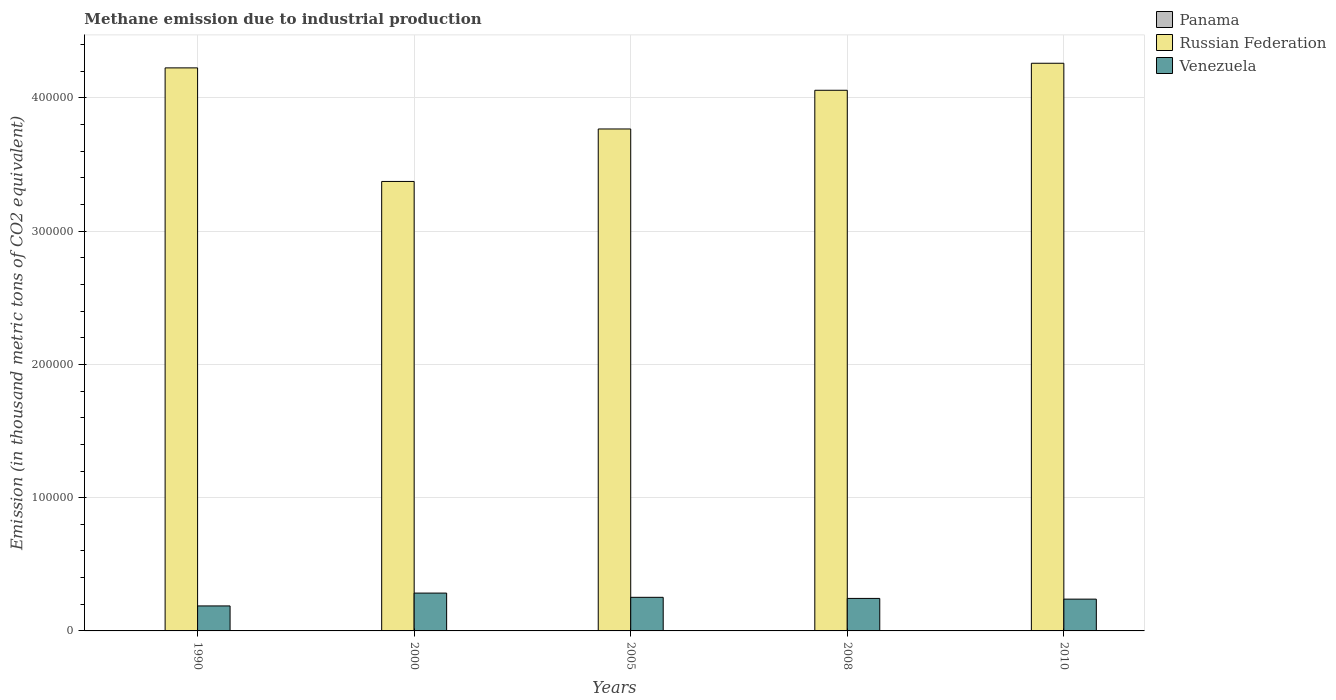How many different coloured bars are there?
Offer a terse response. 3. How many groups of bars are there?
Make the answer very short. 5. What is the label of the 2nd group of bars from the left?
Offer a terse response. 2000. In how many cases, is the number of bars for a given year not equal to the number of legend labels?
Offer a terse response. 0. What is the amount of methane emitted in Russian Federation in 2010?
Keep it short and to the point. 4.26e+05. Across all years, what is the maximum amount of methane emitted in Russian Federation?
Your response must be concise. 4.26e+05. Across all years, what is the minimum amount of methane emitted in Venezuela?
Offer a terse response. 1.88e+04. What is the total amount of methane emitted in Venezuela in the graph?
Provide a short and direct response. 1.21e+05. What is the difference between the amount of methane emitted in Panama in 1990 and that in 2005?
Your response must be concise. -6.9. What is the difference between the amount of methane emitted in Russian Federation in 2008 and the amount of methane emitted in Venezuela in 2005?
Ensure brevity in your answer.  3.81e+05. What is the average amount of methane emitted in Panama per year?
Keep it short and to the point. 137.14. In the year 2010, what is the difference between the amount of methane emitted in Venezuela and amount of methane emitted in Russian Federation?
Your answer should be very brief. -4.02e+05. What is the ratio of the amount of methane emitted in Russian Federation in 2000 to that in 2005?
Provide a short and direct response. 0.9. Is the amount of methane emitted in Venezuela in 2000 less than that in 2005?
Offer a very short reply. No. What is the difference between the highest and the second highest amount of methane emitted in Russian Federation?
Make the answer very short. 3466. What is the difference between the highest and the lowest amount of methane emitted in Venezuela?
Your response must be concise. 9645.4. In how many years, is the amount of methane emitted in Russian Federation greater than the average amount of methane emitted in Russian Federation taken over all years?
Give a very brief answer. 3. Is the sum of the amount of methane emitted in Russian Federation in 2000 and 2010 greater than the maximum amount of methane emitted in Venezuela across all years?
Offer a terse response. Yes. What does the 1st bar from the left in 2005 represents?
Keep it short and to the point. Panama. What does the 2nd bar from the right in 2008 represents?
Your answer should be compact. Russian Federation. Is it the case that in every year, the sum of the amount of methane emitted in Panama and amount of methane emitted in Russian Federation is greater than the amount of methane emitted in Venezuela?
Your answer should be compact. Yes. How many bars are there?
Your answer should be very brief. 15. Are all the bars in the graph horizontal?
Keep it short and to the point. No. Does the graph contain grids?
Provide a short and direct response. Yes. How many legend labels are there?
Your response must be concise. 3. How are the legend labels stacked?
Make the answer very short. Vertical. What is the title of the graph?
Provide a succinct answer. Methane emission due to industrial production. Does "Syrian Arab Republic" appear as one of the legend labels in the graph?
Keep it short and to the point. No. What is the label or title of the Y-axis?
Your answer should be very brief. Emission (in thousand metric tons of CO2 equivalent). What is the Emission (in thousand metric tons of CO2 equivalent) in Panama in 1990?
Provide a succinct answer. 128.9. What is the Emission (in thousand metric tons of CO2 equivalent) in Russian Federation in 1990?
Keep it short and to the point. 4.23e+05. What is the Emission (in thousand metric tons of CO2 equivalent) of Venezuela in 1990?
Keep it short and to the point. 1.88e+04. What is the Emission (in thousand metric tons of CO2 equivalent) in Panama in 2000?
Your answer should be very brief. 161.8. What is the Emission (in thousand metric tons of CO2 equivalent) of Russian Federation in 2000?
Offer a terse response. 3.37e+05. What is the Emission (in thousand metric tons of CO2 equivalent) in Venezuela in 2000?
Ensure brevity in your answer.  2.84e+04. What is the Emission (in thousand metric tons of CO2 equivalent) of Panama in 2005?
Offer a terse response. 135.8. What is the Emission (in thousand metric tons of CO2 equivalent) in Russian Federation in 2005?
Ensure brevity in your answer.  3.77e+05. What is the Emission (in thousand metric tons of CO2 equivalent) of Venezuela in 2005?
Provide a short and direct response. 2.52e+04. What is the Emission (in thousand metric tons of CO2 equivalent) in Panama in 2008?
Provide a succinct answer. 135.3. What is the Emission (in thousand metric tons of CO2 equivalent) of Russian Federation in 2008?
Offer a terse response. 4.06e+05. What is the Emission (in thousand metric tons of CO2 equivalent) of Venezuela in 2008?
Your response must be concise. 2.44e+04. What is the Emission (in thousand metric tons of CO2 equivalent) of Panama in 2010?
Provide a succinct answer. 123.9. What is the Emission (in thousand metric tons of CO2 equivalent) in Russian Federation in 2010?
Provide a short and direct response. 4.26e+05. What is the Emission (in thousand metric tons of CO2 equivalent) of Venezuela in 2010?
Provide a succinct answer. 2.39e+04. Across all years, what is the maximum Emission (in thousand metric tons of CO2 equivalent) of Panama?
Ensure brevity in your answer.  161.8. Across all years, what is the maximum Emission (in thousand metric tons of CO2 equivalent) of Russian Federation?
Keep it short and to the point. 4.26e+05. Across all years, what is the maximum Emission (in thousand metric tons of CO2 equivalent) in Venezuela?
Provide a short and direct response. 2.84e+04. Across all years, what is the minimum Emission (in thousand metric tons of CO2 equivalent) of Panama?
Your answer should be very brief. 123.9. Across all years, what is the minimum Emission (in thousand metric tons of CO2 equivalent) of Russian Federation?
Offer a very short reply. 3.37e+05. Across all years, what is the minimum Emission (in thousand metric tons of CO2 equivalent) of Venezuela?
Keep it short and to the point. 1.88e+04. What is the total Emission (in thousand metric tons of CO2 equivalent) in Panama in the graph?
Offer a very short reply. 685.7. What is the total Emission (in thousand metric tons of CO2 equivalent) of Russian Federation in the graph?
Make the answer very short. 1.97e+06. What is the total Emission (in thousand metric tons of CO2 equivalent) in Venezuela in the graph?
Provide a succinct answer. 1.21e+05. What is the difference between the Emission (in thousand metric tons of CO2 equivalent) in Panama in 1990 and that in 2000?
Keep it short and to the point. -32.9. What is the difference between the Emission (in thousand metric tons of CO2 equivalent) in Russian Federation in 1990 and that in 2000?
Give a very brief answer. 8.52e+04. What is the difference between the Emission (in thousand metric tons of CO2 equivalent) of Venezuela in 1990 and that in 2000?
Provide a succinct answer. -9645.4. What is the difference between the Emission (in thousand metric tons of CO2 equivalent) in Russian Federation in 1990 and that in 2005?
Provide a short and direct response. 4.58e+04. What is the difference between the Emission (in thousand metric tons of CO2 equivalent) of Venezuela in 1990 and that in 2005?
Ensure brevity in your answer.  -6462.5. What is the difference between the Emission (in thousand metric tons of CO2 equivalent) in Russian Federation in 1990 and that in 2008?
Your answer should be compact. 1.68e+04. What is the difference between the Emission (in thousand metric tons of CO2 equivalent) in Venezuela in 1990 and that in 2008?
Make the answer very short. -5639.8. What is the difference between the Emission (in thousand metric tons of CO2 equivalent) in Panama in 1990 and that in 2010?
Your answer should be compact. 5. What is the difference between the Emission (in thousand metric tons of CO2 equivalent) of Russian Federation in 1990 and that in 2010?
Give a very brief answer. -3466. What is the difference between the Emission (in thousand metric tons of CO2 equivalent) in Venezuela in 1990 and that in 2010?
Offer a very short reply. -5098.4. What is the difference between the Emission (in thousand metric tons of CO2 equivalent) in Russian Federation in 2000 and that in 2005?
Keep it short and to the point. -3.94e+04. What is the difference between the Emission (in thousand metric tons of CO2 equivalent) in Venezuela in 2000 and that in 2005?
Offer a terse response. 3182.9. What is the difference between the Emission (in thousand metric tons of CO2 equivalent) in Panama in 2000 and that in 2008?
Your answer should be very brief. 26.5. What is the difference between the Emission (in thousand metric tons of CO2 equivalent) of Russian Federation in 2000 and that in 2008?
Give a very brief answer. -6.84e+04. What is the difference between the Emission (in thousand metric tons of CO2 equivalent) in Venezuela in 2000 and that in 2008?
Your answer should be very brief. 4005.6. What is the difference between the Emission (in thousand metric tons of CO2 equivalent) in Panama in 2000 and that in 2010?
Your response must be concise. 37.9. What is the difference between the Emission (in thousand metric tons of CO2 equivalent) in Russian Federation in 2000 and that in 2010?
Provide a short and direct response. -8.87e+04. What is the difference between the Emission (in thousand metric tons of CO2 equivalent) in Venezuela in 2000 and that in 2010?
Give a very brief answer. 4547. What is the difference between the Emission (in thousand metric tons of CO2 equivalent) in Russian Federation in 2005 and that in 2008?
Offer a very short reply. -2.90e+04. What is the difference between the Emission (in thousand metric tons of CO2 equivalent) in Venezuela in 2005 and that in 2008?
Your response must be concise. 822.7. What is the difference between the Emission (in thousand metric tons of CO2 equivalent) of Panama in 2005 and that in 2010?
Give a very brief answer. 11.9. What is the difference between the Emission (in thousand metric tons of CO2 equivalent) in Russian Federation in 2005 and that in 2010?
Provide a succinct answer. -4.93e+04. What is the difference between the Emission (in thousand metric tons of CO2 equivalent) in Venezuela in 2005 and that in 2010?
Provide a succinct answer. 1364.1. What is the difference between the Emission (in thousand metric tons of CO2 equivalent) in Panama in 2008 and that in 2010?
Provide a short and direct response. 11.4. What is the difference between the Emission (in thousand metric tons of CO2 equivalent) in Russian Federation in 2008 and that in 2010?
Ensure brevity in your answer.  -2.03e+04. What is the difference between the Emission (in thousand metric tons of CO2 equivalent) of Venezuela in 2008 and that in 2010?
Your response must be concise. 541.4. What is the difference between the Emission (in thousand metric tons of CO2 equivalent) in Panama in 1990 and the Emission (in thousand metric tons of CO2 equivalent) in Russian Federation in 2000?
Make the answer very short. -3.37e+05. What is the difference between the Emission (in thousand metric tons of CO2 equivalent) in Panama in 1990 and the Emission (in thousand metric tons of CO2 equivalent) in Venezuela in 2000?
Ensure brevity in your answer.  -2.83e+04. What is the difference between the Emission (in thousand metric tons of CO2 equivalent) in Russian Federation in 1990 and the Emission (in thousand metric tons of CO2 equivalent) in Venezuela in 2000?
Your response must be concise. 3.94e+05. What is the difference between the Emission (in thousand metric tons of CO2 equivalent) of Panama in 1990 and the Emission (in thousand metric tons of CO2 equivalent) of Russian Federation in 2005?
Your answer should be compact. -3.77e+05. What is the difference between the Emission (in thousand metric tons of CO2 equivalent) of Panama in 1990 and the Emission (in thousand metric tons of CO2 equivalent) of Venezuela in 2005?
Keep it short and to the point. -2.51e+04. What is the difference between the Emission (in thousand metric tons of CO2 equivalent) in Russian Federation in 1990 and the Emission (in thousand metric tons of CO2 equivalent) in Venezuela in 2005?
Provide a short and direct response. 3.97e+05. What is the difference between the Emission (in thousand metric tons of CO2 equivalent) in Panama in 1990 and the Emission (in thousand metric tons of CO2 equivalent) in Russian Federation in 2008?
Provide a succinct answer. -4.06e+05. What is the difference between the Emission (in thousand metric tons of CO2 equivalent) in Panama in 1990 and the Emission (in thousand metric tons of CO2 equivalent) in Venezuela in 2008?
Provide a succinct answer. -2.43e+04. What is the difference between the Emission (in thousand metric tons of CO2 equivalent) in Russian Federation in 1990 and the Emission (in thousand metric tons of CO2 equivalent) in Venezuela in 2008?
Keep it short and to the point. 3.98e+05. What is the difference between the Emission (in thousand metric tons of CO2 equivalent) of Panama in 1990 and the Emission (in thousand metric tons of CO2 equivalent) of Russian Federation in 2010?
Offer a very short reply. -4.26e+05. What is the difference between the Emission (in thousand metric tons of CO2 equivalent) in Panama in 1990 and the Emission (in thousand metric tons of CO2 equivalent) in Venezuela in 2010?
Your answer should be compact. -2.37e+04. What is the difference between the Emission (in thousand metric tons of CO2 equivalent) in Russian Federation in 1990 and the Emission (in thousand metric tons of CO2 equivalent) in Venezuela in 2010?
Provide a succinct answer. 3.99e+05. What is the difference between the Emission (in thousand metric tons of CO2 equivalent) in Panama in 2000 and the Emission (in thousand metric tons of CO2 equivalent) in Russian Federation in 2005?
Keep it short and to the point. -3.77e+05. What is the difference between the Emission (in thousand metric tons of CO2 equivalent) of Panama in 2000 and the Emission (in thousand metric tons of CO2 equivalent) of Venezuela in 2005?
Keep it short and to the point. -2.51e+04. What is the difference between the Emission (in thousand metric tons of CO2 equivalent) of Russian Federation in 2000 and the Emission (in thousand metric tons of CO2 equivalent) of Venezuela in 2005?
Make the answer very short. 3.12e+05. What is the difference between the Emission (in thousand metric tons of CO2 equivalent) in Panama in 2000 and the Emission (in thousand metric tons of CO2 equivalent) in Russian Federation in 2008?
Your response must be concise. -4.06e+05. What is the difference between the Emission (in thousand metric tons of CO2 equivalent) in Panama in 2000 and the Emission (in thousand metric tons of CO2 equivalent) in Venezuela in 2008?
Your answer should be very brief. -2.42e+04. What is the difference between the Emission (in thousand metric tons of CO2 equivalent) of Russian Federation in 2000 and the Emission (in thousand metric tons of CO2 equivalent) of Venezuela in 2008?
Your response must be concise. 3.13e+05. What is the difference between the Emission (in thousand metric tons of CO2 equivalent) of Panama in 2000 and the Emission (in thousand metric tons of CO2 equivalent) of Russian Federation in 2010?
Your response must be concise. -4.26e+05. What is the difference between the Emission (in thousand metric tons of CO2 equivalent) of Panama in 2000 and the Emission (in thousand metric tons of CO2 equivalent) of Venezuela in 2010?
Keep it short and to the point. -2.37e+04. What is the difference between the Emission (in thousand metric tons of CO2 equivalent) in Russian Federation in 2000 and the Emission (in thousand metric tons of CO2 equivalent) in Venezuela in 2010?
Provide a succinct answer. 3.13e+05. What is the difference between the Emission (in thousand metric tons of CO2 equivalent) of Panama in 2005 and the Emission (in thousand metric tons of CO2 equivalent) of Russian Federation in 2008?
Offer a very short reply. -4.06e+05. What is the difference between the Emission (in thousand metric tons of CO2 equivalent) of Panama in 2005 and the Emission (in thousand metric tons of CO2 equivalent) of Venezuela in 2008?
Ensure brevity in your answer.  -2.43e+04. What is the difference between the Emission (in thousand metric tons of CO2 equivalent) of Russian Federation in 2005 and the Emission (in thousand metric tons of CO2 equivalent) of Venezuela in 2008?
Your response must be concise. 3.52e+05. What is the difference between the Emission (in thousand metric tons of CO2 equivalent) of Panama in 2005 and the Emission (in thousand metric tons of CO2 equivalent) of Russian Federation in 2010?
Offer a very short reply. -4.26e+05. What is the difference between the Emission (in thousand metric tons of CO2 equivalent) of Panama in 2005 and the Emission (in thousand metric tons of CO2 equivalent) of Venezuela in 2010?
Provide a short and direct response. -2.37e+04. What is the difference between the Emission (in thousand metric tons of CO2 equivalent) of Russian Federation in 2005 and the Emission (in thousand metric tons of CO2 equivalent) of Venezuela in 2010?
Ensure brevity in your answer.  3.53e+05. What is the difference between the Emission (in thousand metric tons of CO2 equivalent) of Panama in 2008 and the Emission (in thousand metric tons of CO2 equivalent) of Russian Federation in 2010?
Give a very brief answer. -4.26e+05. What is the difference between the Emission (in thousand metric tons of CO2 equivalent) of Panama in 2008 and the Emission (in thousand metric tons of CO2 equivalent) of Venezuela in 2010?
Your response must be concise. -2.37e+04. What is the difference between the Emission (in thousand metric tons of CO2 equivalent) in Russian Federation in 2008 and the Emission (in thousand metric tons of CO2 equivalent) in Venezuela in 2010?
Make the answer very short. 3.82e+05. What is the average Emission (in thousand metric tons of CO2 equivalent) in Panama per year?
Provide a short and direct response. 137.14. What is the average Emission (in thousand metric tons of CO2 equivalent) of Russian Federation per year?
Your answer should be compact. 3.94e+05. What is the average Emission (in thousand metric tons of CO2 equivalent) in Venezuela per year?
Offer a terse response. 2.41e+04. In the year 1990, what is the difference between the Emission (in thousand metric tons of CO2 equivalent) in Panama and Emission (in thousand metric tons of CO2 equivalent) in Russian Federation?
Offer a terse response. -4.22e+05. In the year 1990, what is the difference between the Emission (in thousand metric tons of CO2 equivalent) in Panama and Emission (in thousand metric tons of CO2 equivalent) in Venezuela?
Provide a short and direct response. -1.86e+04. In the year 1990, what is the difference between the Emission (in thousand metric tons of CO2 equivalent) of Russian Federation and Emission (in thousand metric tons of CO2 equivalent) of Venezuela?
Your response must be concise. 4.04e+05. In the year 2000, what is the difference between the Emission (in thousand metric tons of CO2 equivalent) in Panama and Emission (in thousand metric tons of CO2 equivalent) in Russian Federation?
Your answer should be very brief. -3.37e+05. In the year 2000, what is the difference between the Emission (in thousand metric tons of CO2 equivalent) of Panama and Emission (in thousand metric tons of CO2 equivalent) of Venezuela?
Give a very brief answer. -2.82e+04. In the year 2000, what is the difference between the Emission (in thousand metric tons of CO2 equivalent) in Russian Federation and Emission (in thousand metric tons of CO2 equivalent) in Venezuela?
Keep it short and to the point. 3.09e+05. In the year 2005, what is the difference between the Emission (in thousand metric tons of CO2 equivalent) of Panama and Emission (in thousand metric tons of CO2 equivalent) of Russian Federation?
Give a very brief answer. -3.77e+05. In the year 2005, what is the difference between the Emission (in thousand metric tons of CO2 equivalent) in Panama and Emission (in thousand metric tons of CO2 equivalent) in Venezuela?
Your response must be concise. -2.51e+04. In the year 2005, what is the difference between the Emission (in thousand metric tons of CO2 equivalent) of Russian Federation and Emission (in thousand metric tons of CO2 equivalent) of Venezuela?
Provide a succinct answer. 3.51e+05. In the year 2008, what is the difference between the Emission (in thousand metric tons of CO2 equivalent) in Panama and Emission (in thousand metric tons of CO2 equivalent) in Russian Federation?
Provide a short and direct response. -4.06e+05. In the year 2008, what is the difference between the Emission (in thousand metric tons of CO2 equivalent) of Panama and Emission (in thousand metric tons of CO2 equivalent) of Venezuela?
Your response must be concise. -2.43e+04. In the year 2008, what is the difference between the Emission (in thousand metric tons of CO2 equivalent) in Russian Federation and Emission (in thousand metric tons of CO2 equivalent) in Venezuela?
Offer a terse response. 3.81e+05. In the year 2010, what is the difference between the Emission (in thousand metric tons of CO2 equivalent) in Panama and Emission (in thousand metric tons of CO2 equivalent) in Russian Federation?
Offer a terse response. -4.26e+05. In the year 2010, what is the difference between the Emission (in thousand metric tons of CO2 equivalent) in Panama and Emission (in thousand metric tons of CO2 equivalent) in Venezuela?
Provide a short and direct response. -2.37e+04. In the year 2010, what is the difference between the Emission (in thousand metric tons of CO2 equivalent) in Russian Federation and Emission (in thousand metric tons of CO2 equivalent) in Venezuela?
Your answer should be very brief. 4.02e+05. What is the ratio of the Emission (in thousand metric tons of CO2 equivalent) of Panama in 1990 to that in 2000?
Your answer should be compact. 0.8. What is the ratio of the Emission (in thousand metric tons of CO2 equivalent) in Russian Federation in 1990 to that in 2000?
Offer a very short reply. 1.25. What is the ratio of the Emission (in thousand metric tons of CO2 equivalent) in Venezuela in 1990 to that in 2000?
Give a very brief answer. 0.66. What is the ratio of the Emission (in thousand metric tons of CO2 equivalent) in Panama in 1990 to that in 2005?
Offer a very short reply. 0.95. What is the ratio of the Emission (in thousand metric tons of CO2 equivalent) in Russian Federation in 1990 to that in 2005?
Keep it short and to the point. 1.12. What is the ratio of the Emission (in thousand metric tons of CO2 equivalent) of Venezuela in 1990 to that in 2005?
Make the answer very short. 0.74. What is the ratio of the Emission (in thousand metric tons of CO2 equivalent) in Panama in 1990 to that in 2008?
Your answer should be compact. 0.95. What is the ratio of the Emission (in thousand metric tons of CO2 equivalent) in Russian Federation in 1990 to that in 2008?
Ensure brevity in your answer.  1.04. What is the ratio of the Emission (in thousand metric tons of CO2 equivalent) of Venezuela in 1990 to that in 2008?
Keep it short and to the point. 0.77. What is the ratio of the Emission (in thousand metric tons of CO2 equivalent) of Panama in 1990 to that in 2010?
Provide a succinct answer. 1.04. What is the ratio of the Emission (in thousand metric tons of CO2 equivalent) in Venezuela in 1990 to that in 2010?
Provide a short and direct response. 0.79. What is the ratio of the Emission (in thousand metric tons of CO2 equivalent) in Panama in 2000 to that in 2005?
Keep it short and to the point. 1.19. What is the ratio of the Emission (in thousand metric tons of CO2 equivalent) of Russian Federation in 2000 to that in 2005?
Make the answer very short. 0.9. What is the ratio of the Emission (in thousand metric tons of CO2 equivalent) of Venezuela in 2000 to that in 2005?
Provide a short and direct response. 1.13. What is the ratio of the Emission (in thousand metric tons of CO2 equivalent) of Panama in 2000 to that in 2008?
Provide a short and direct response. 1.2. What is the ratio of the Emission (in thousand metric tons of CO2 equivalent) of Russian Federation in 2000 to that in 2008?
Your answer should be very brief. 0.83. What is the ratio of the Emission (in thousand metric tons of CO2 equivalent) of Venezuela in 2000 to that in 2008?
Provide a short and direct response. 1.16. What is the ratio of the Emission (in thousand metric tons of CO2 equivalent) in Panama in 2000 to that in 2010?
Give a very brief answer. 1.31. What is the ratio of the Emission (in thousand metric tons of CO2 equivalent) of Russian Federation in 2000 to that in 2010?
Offer a terse response. 0.79. What is the ratio of the Emission (in thousand metric tons of CO2 equivalent) of Venezuela in 2000 to that in 2010?
Provide a succinct answer. 1.19. What is the ratio of the Emission (in thousand metric tons of CO2 equivalent) in Russian Federation in 2005 to that in 2008?
Keep it short and to the point. 0.93. What is the ratio of the Emission (in thousand metric tons of CO2 equivalent) of Venezuela in 2005 to that in 2008?
Your answer should be very brief. 1.03. What is the ratio of the Emission (in thousand metric tons of CO2 equivalent) in Panama in 2005 to that in 2010?
Your answer should be very brief. 1.1. What is the ratio of the Emission (in thousand metric tons of CO2 equivalent) of Russian Federation in 2005 to that in 2010?
Offer a terse response. 0.88. What is the ratio of the Emission (in thousand metric tons of CO2 equivalent) of Venezuela in 2005 to that in 2010?
Keep it short and to the point. 1.06. What is the ratio of the Emission (in thousand metric tons of CO2 equivalent) in Panama in 2008 to that in 2010?
Offer a terse response. 1.09. What is the ratio of the Emission (in thousand metric tons of CO2 equivalent) in Russian Federation in 2008 to that in 2010?
Your response must be concise. 0.95. What is the ratio of the Emission (in thousand metric tons of CO2 equivalent) in Venezuela in 2008 to that in 2010?
Offer a very short reply. 1.02. What is the difference between the highest and the second highest Emission (in thousand metric tons of CO2 equivalent) in Russian Federation?
Ensure brevity in your answer.  3466. What is the difference between the highest and the second highest Emission (in thousand metric tons of CO2 equivalent) in Venezuela?
Your answer should be very brief. 3182.9. What is the difference between the highest and the lowest Emission (in thousand metric tons of CO2 equivalent) of Panama?
Ensure brevity in your answer.  37.9. What is the difference between the highest and the lowest Emission (in thousand metric tons of CO2 equivalent) of Russian Federation?
Give a very brief answer. 8.87e+04. What is the difference between the highest and the lowest Emission (in thousand metric tons of CO2 equivalent) in Venezuela?
Your response must be concise. 9645.4. 